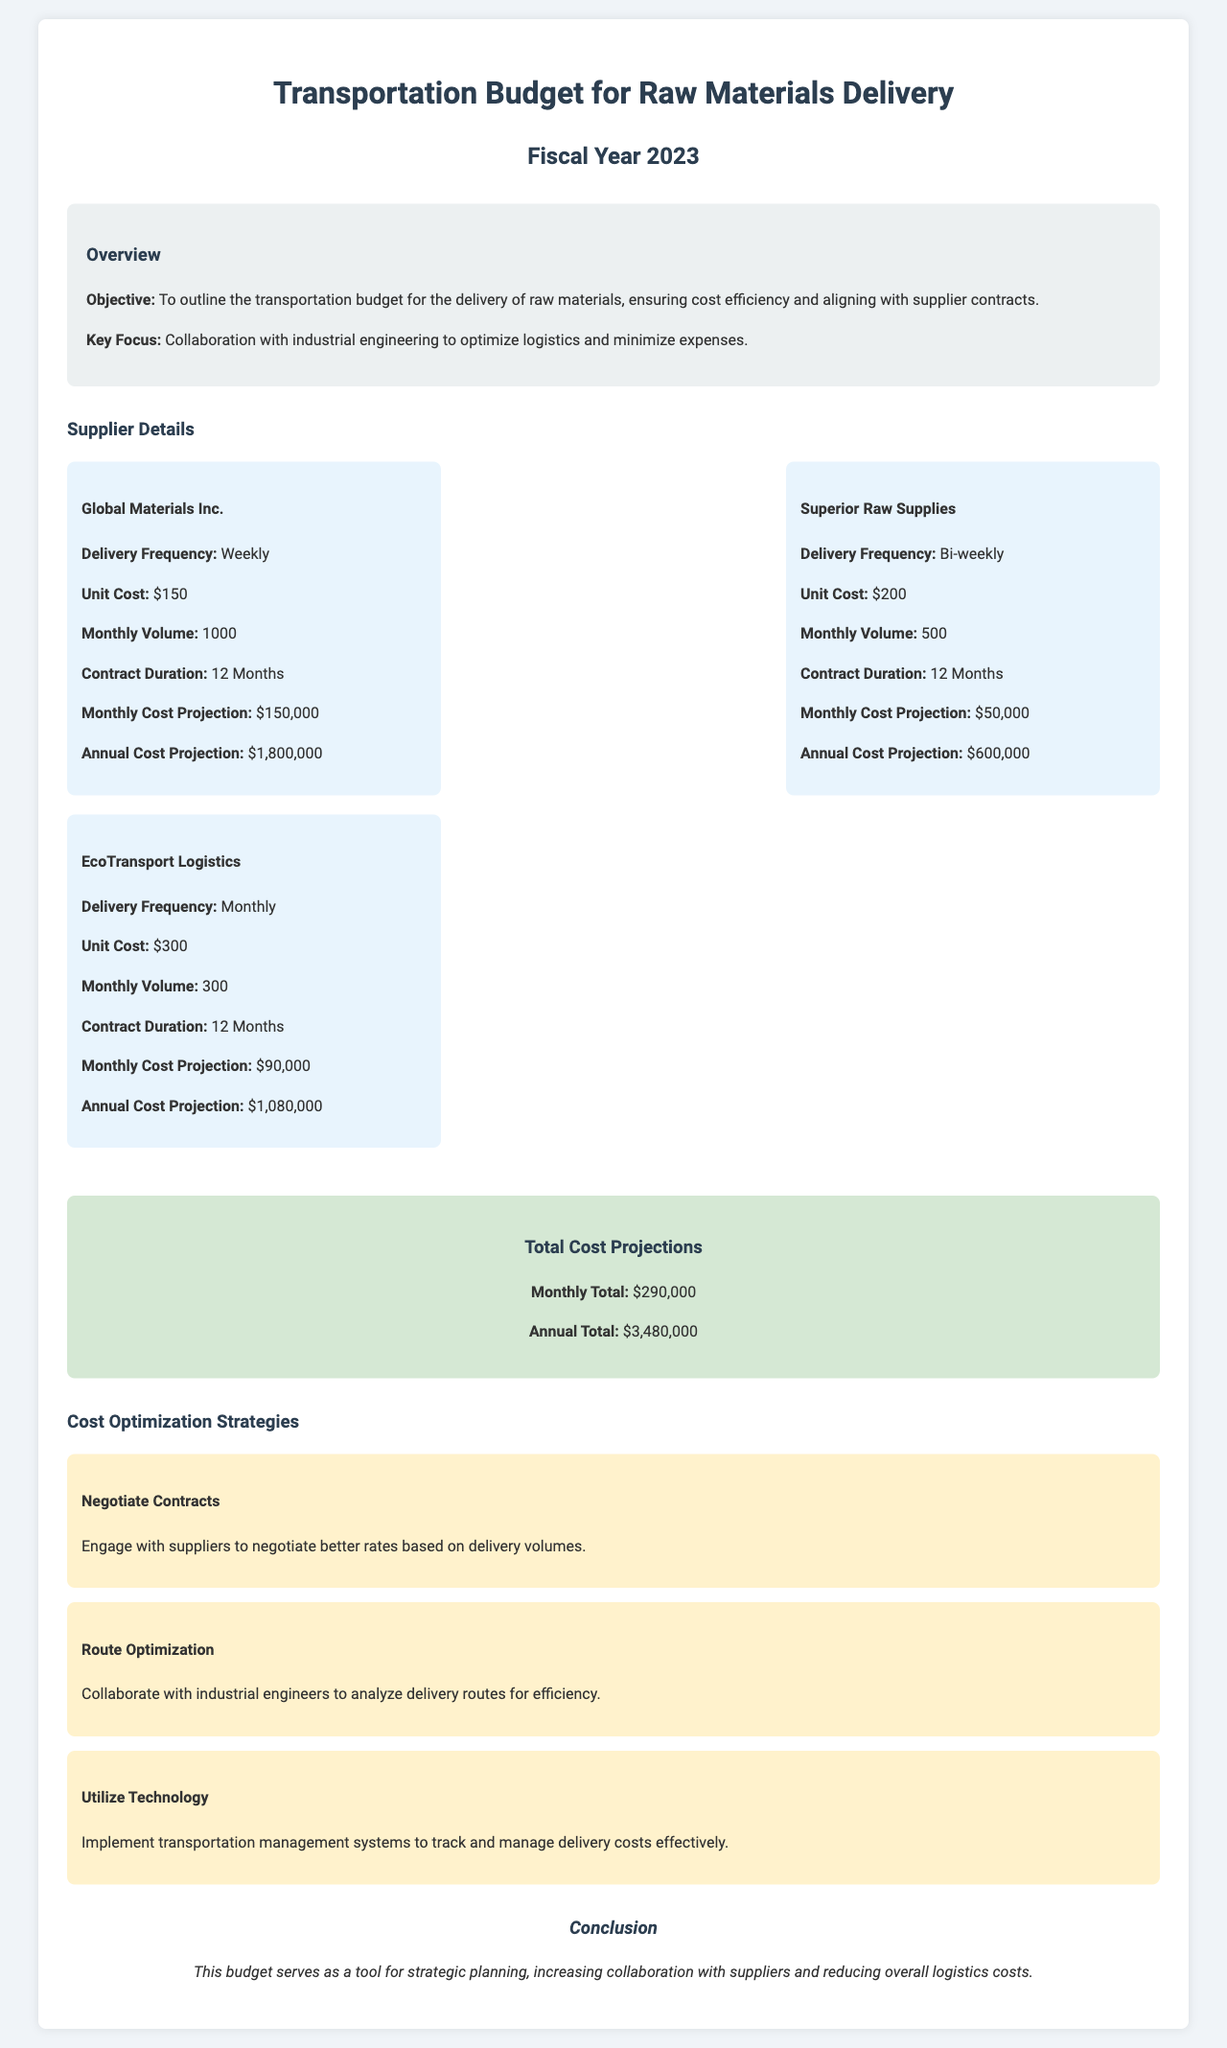What is the total annual cost projection? The total annual cost projection for transportation is calculated from the monthly cost projections from all suppliers combined.
Answer: $3,480,000 What is the unit cost for EcoTransport Logistics? The unit cost is specifically listed for each supplier; EcoTransport Logistics has a unit cost of $300.
Answer: $300 How frequently does Global Materials Inc. deliver? The delivery frequency for each supplier is outlined; Global Materials Inc. delivers weekly.
Answer: Weekly What is the monthly volume for Superior Raw Supplies? The document specifies a monthly volume for each supplier; Superior Raw Supplies has a monthly volume of 500.
Answer: 500 What are the three cost optimization strategies mentioned in the document? The document lists specific strategies aimed at cost optimization, which include negotiating contracts, route optimization, and utilizing technology.
Answer: Negotiate Contracts, Route Optimization, Utilize Technology What is the total monthly cost projection? The total monthly cost projection is derived from adding the monthly cost projections of all suppliers.
Answer: $290,000 What is the contract duration for all suppliers? Each supplier's contract duration is stated; all suppliers have a contract duration of 12 months.
Answer: 12 Months What is the monthly cost projection for EcoTransport Logistics? The monthly cost projection for EcoTransport Logistics is detailed in the supplier section of the document.
Answer: $90,000 What is the key focus of the transportation budget? The key focus of the budget is articulated under the overview section aiming for optimization.
Answer: Collaboration with industrial engineering to optimize logistics and minimize expenses 